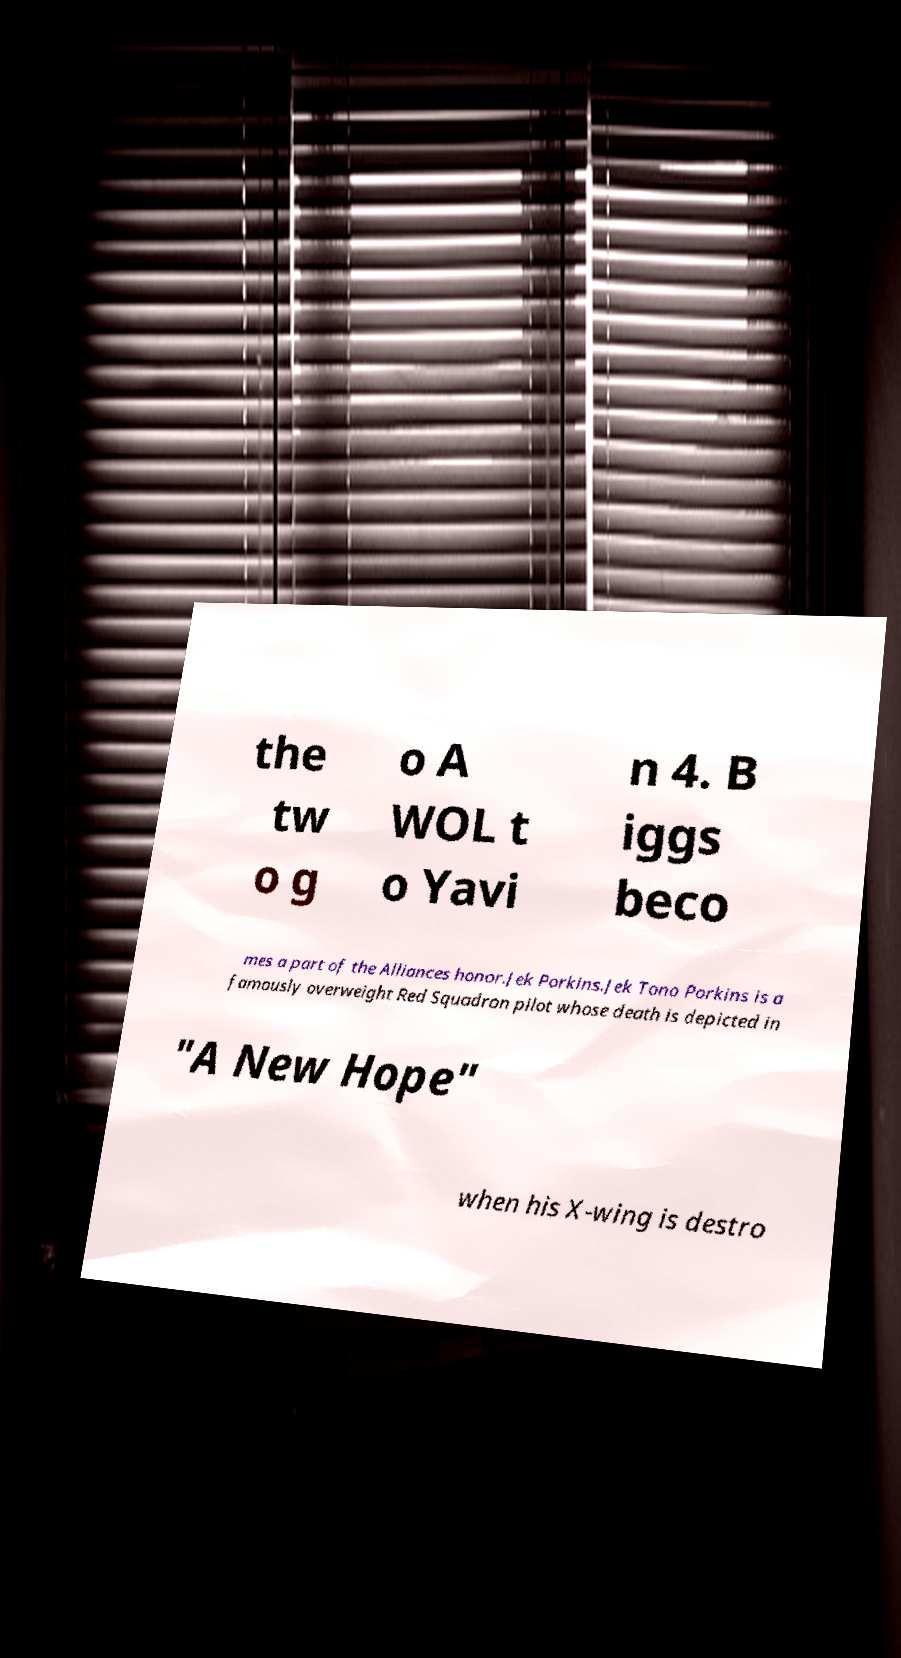Can you accurately transcribe the text from the provided image for me? the tw o g o A WOL t o Yavi n 4. B iggs beco mes a part of the Alliances honor.Jek Porkins.Jek Tono Porkins is a famously overweight Red Squadron pilot whose death is depicted in "A New Hope" when his X-wing is destro 